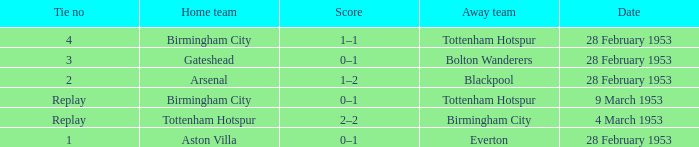Which Home team has a Score of 0–1, and an Away team of tottenham hotspur? Birmingham City. 